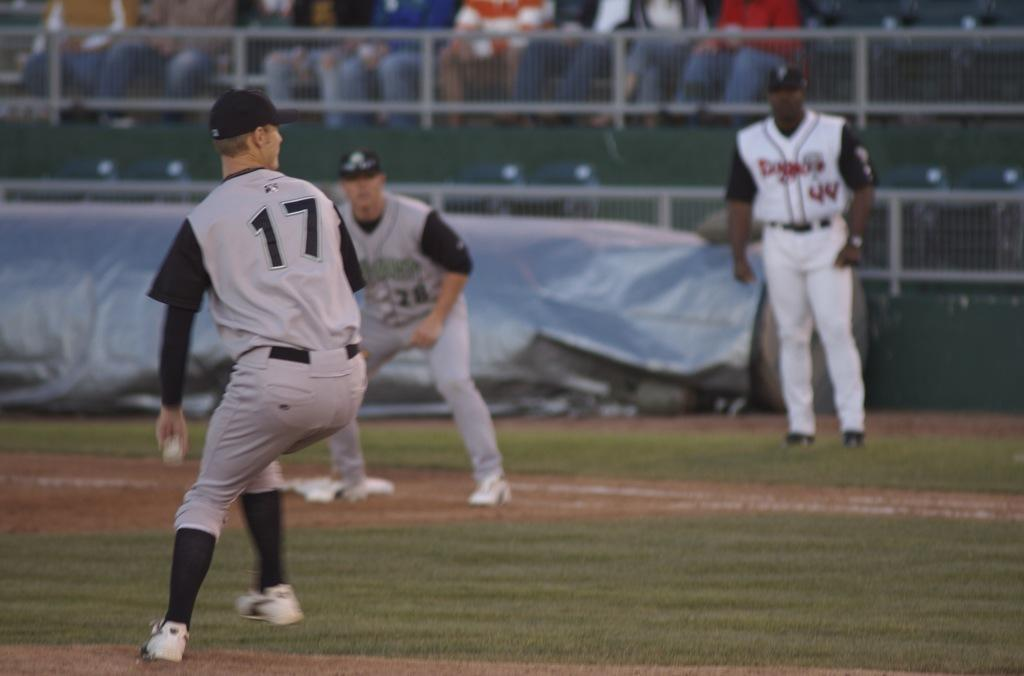Provide a one-sentence caption for the provided image. Number 17 gets ready to throw the ball while 2 other players look on. 